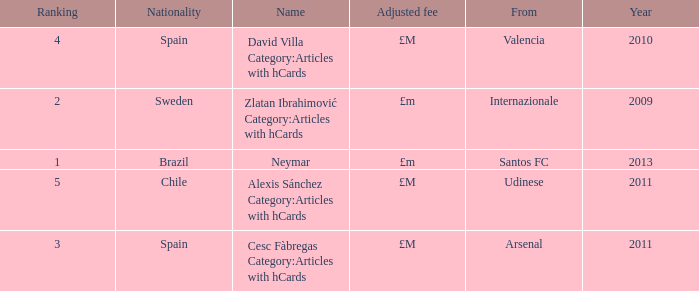Where is the ranked 2 players from? Internazionale. 